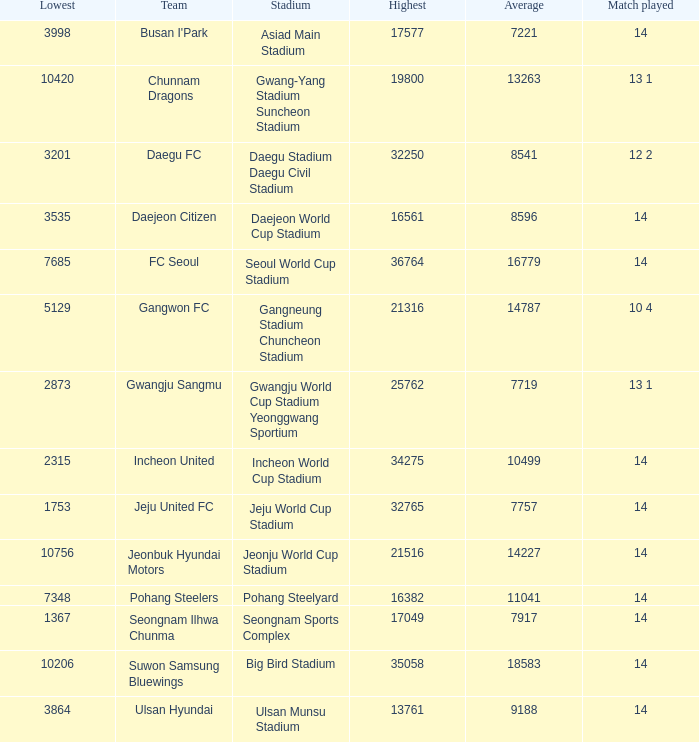What is the lowest when pohang steelyard is the stadium? 7348.0. 